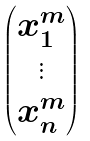Convert formula to latex. <formula><loc_0><loc_0><loc_500><loc_500>\begin{pmatrix} x _ { 1 } ^ { m } \\ \vdots \\ x _ { n } ^ { m } \end{pmatrix}</formula> 